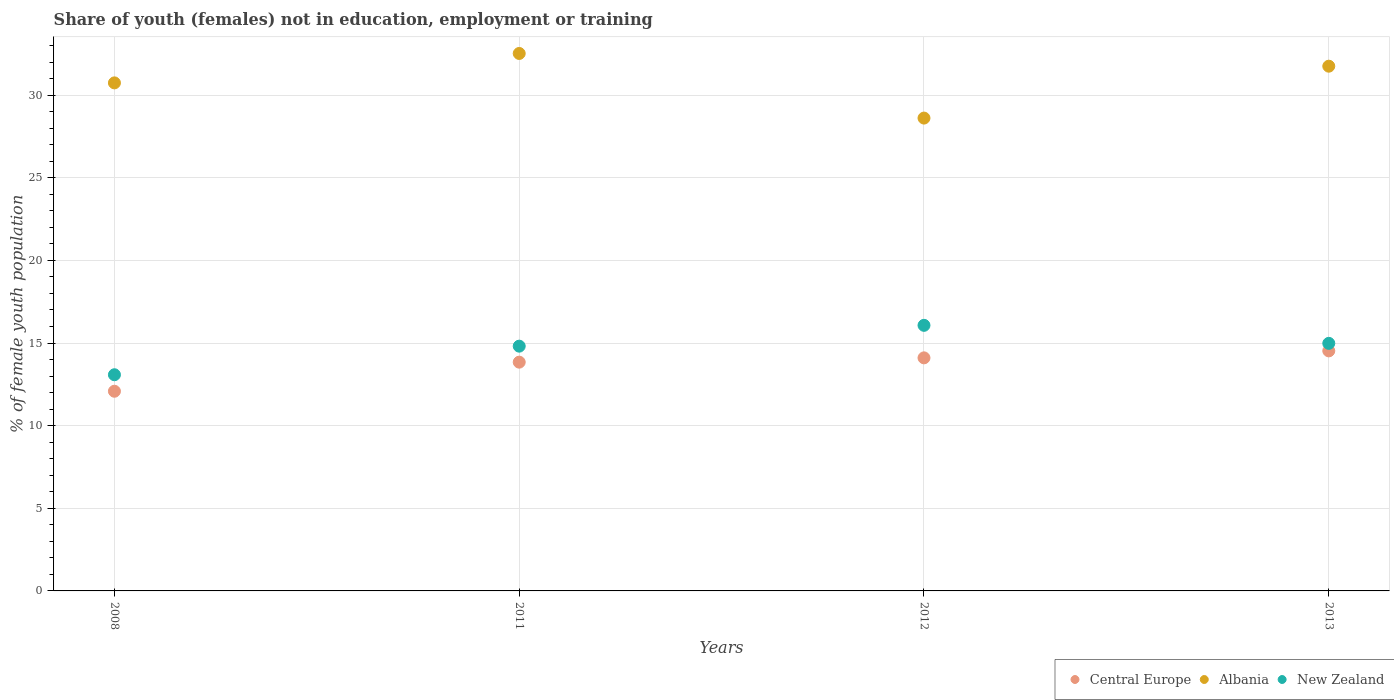How many different coloured dotlines are there?
Offer a very short reply. 3. Is the number of dotlines equal to the number of legend labels?
Offer a very short reply. Yes. What is the percentage of unemployed female population in in Albania in 2011?
Ensure brevity in your answer.  32.52. Across all years, what is the maximum percentage of unemployed female population in in Central Europe?
Offer a terse response. 14.52. Across all years, what is the minimum percentage of unemployed female population in in New Zealand?
Make the answer very short. 13.08. In which year was the percentage of unemployed female population in in New Zealand maximum?
Provide a succinct answer. 2012. In which year was the percentage of unemployed female population in in Central Europe minimum?
Provide a succinct answer. 2008. What is the total percentage of unemployed female population in in Albania in the graph?
Offer a terse response. 123.62. What is the difference between the percentage of unemployed female population in in Central Europe in 2012 and that in 2013?
Your response must be concise. -0.42. What is the difference between the percentage of unemployed female population in in New Zealand in 2008 and the percentage of unemployed female population in in Albania in 2012?
Offer a terse response. -15.53. What is the average percentage of unemployed female population in in Albania per year?
Your answer should be compact. 30.91. In the year 2012, what is the difference between the percentage of unemployed female population in in New Zealand and percentage of unemployed female population in in Central Europe?
Your response must be concise. 1.97. In how many years, is the percentage of unemployed female population in in New Zealand greater than 18 %?
Provide a succinct answer. 0. What is the ratio of the percentage of unemployed female population in in Albania in 2008 to that in 2011?
Offer a terse response. 0.95. What is the difference between the highest and the second highest percentage of unemployed female population in in Central Europe?
Ensure brevity in your answer.  0.42. What is the difference between the highest and the lowest percentage of unemployed female population in in Central Europe?
Offer a terse response. 2.44. In how many years, is the percentage of unemployed female population in in New Zealand greater than the average percentage of unemployed female population in in New Zealand taken over all years?
Keep it short and to the point. 3. Does the percentage of unemployed female population in in Albania monotonically increase over the years?
Ensure brevity in your answer.  No. Is the percentage of unemployed female population in in Central Europe strictly less than the percentage of unemployed female population in in Albania over the years?
Your response must be concise. Yes. How many years are there in the graph?
Provide a succinct answer. 4. Does the graph contain any zero values?
Your answer should be very brief. No. Does the graph contain grids?
Your answer should be very brief. Yes. Where does the legend appear in the graph?
Ensure brevity in your answer.  Bottom right. What is the title of the graph?
Your response must be concise. Share of youth (females) not in education, employment or training. Does "Euro area" appear as one of the legend labels in the graph?
Give a very brief answer. No. What is the label or title of the Y-axis?
Your response must be concise. % of female youth population. What is the % of female youth population of Central Europe in 2008?
Make the answer very short. 12.08. What is the % of female youth population in Albania in 2008?
Your response must be concise. 30.74. What is the % of female youth population of New Zealand in 2008?
Your response must be concise. 13.08. What is the % of female youth population of Central Europe in 2011?
Provide a succinct answer. 13.84. What is the % of female youth population of Albania in 2011?
Ensure brevity in your answer.  32.52. What is the % of female youth population in New Zealand in 2011?
Your response must be concise. 14.81. What is the % of female youth population of Central Europe in 2012?
Offer a very short reply. 14.1. What is the % of female youth population of Albania in 2012?
Provide a succinct answer. 28.61. What is the % of female youth population of New Zealand in 2012?
Offer a very short reply. 16.07. What is the % of female youth population of Central Europe in 2013?
Ensure brevity in your answer.  14.52. What is the % of female youth population of Albania in 2013?
Keep it short and to the point. 31.75. What is the % of female youth population in New Zealand in 2013?
Offer a very short reply. 14.98. Across all years, what is the maximum % of female youth population of Central Europe?
Your answer should be compact. 14.52. Across all years, what is the maximum % of female youth population of Albania?
Offer a very short reply. 32.52. Across all years, what is the maximum % of female youth population in New Zealand?
Offer a terse response. 16.07. Across all years, what is the minimum % of female youth population in Central Europe?
Make the answer very short. 12.08. Across all years, what is the minimum % of female youth population of Albania?
Offer a very short reply. 28.61. Across all years, what is the minimum % of female youth population of New Zealand?
Ensure brevity in your answer.  13.08. What is the total % of female youth population in Central Europe in the graph?
Your answer should be very brief. 54.55. What is the total % of female youth population in Albania in the graph?
Give a very brief answer. 123.62. What is the total % of female youth population of New Zealand in the graph?
Offer a very short reply. 58.94. What is the difference between the % of female youth population in Central Europe in 2008 and that in 2011?
Your answer should be very brief. -1.76. What is the difference between the % of female youth population in Albania in 2008 and that in 2011?
Keep it short and to the point. -1.78. What is the difference between the % of female youth population of New Zealand in 2008 and that in 2011?
Provide a succinct answer. -1.73. What is the difference between the % of female youth population of Central Europe in 2008 and that in 2012?
Provide a short and direct response. -2.02. What is the difference between the % of female youth population of Albania in 2008 and that in 2012?
Your answer should be compact. 2.13. What is the difference between the % of female youth population of New Zealand in 2008 and that in 2012?
Make the answer very short. -2.99. What is the difference between the % of female youth population in Central Europe in 2008 and that in 2013?
Keep it short and to the point. -2.44. What is the difference between the % of female youth population in Albania in 2008 and that in 2013?
Your response must be concise. -1.01. What is the difference between the % of female youth population in Central Europe in 2011 and that in 2012?
Your answer should be very brief. -0.26. What is the difference between the % of female youth population of Albania in 2011 and that in 2012?
Offer a terse response. 3.91. What is the difference between the % of female youth population in New Zealand in 2011 and that in 2012?
Make the answer very short. -1.26. What is the difference between the % of female youth population of Central Europe in 2011 and that in 2013?
Your answer should be very brief. -0.68. What is the difference between the % of female youth population of Albania in 2011 and that in 2013?
Your response must be concise. 0.77. What is the difference between the % of female youth population of New Zealand in 2011 and that in 2013?
Make the answer very short. -0.17. What is the difference between the % of female youth population of Central Europe in 2012 and that in 2013?
Give a very brief answer. -0.42. What is the difference between the % of female youth population of Albania in 2012 and that in 2013?
Ensure brevity in your answer.  -3.14. What is the difference between the % of female youth population of New Zealand in 2012 and that in 2013?
Ensure brevity in your answer.  1.09. What is the difference between the % of female youth population of Central Europe in 2008 and the % of female youth population of Albania in 2011?
Give a very brief answer. -20.44. What is the difference between the % of female youth population of Central Europe in 2008 and the % of female youth population of New Zealand in 2011?
Make the answer very short. -2.73. What is the difference between the % of female youth population in Albania in 2008 and the % of female youth population in New Zealand in 2011?
Give a very brief answer. 15.93. What is the difference between the % of female youth population in Central Europe in 2008 and the % of female youth population in Albania in 2012?
Give a very brief answer. -16.53. What is the difference between the % of female youth population of Central Europe in 2008 and the % of female youth population of New Zealand in 2012?
Offer a very short reply. -3.99. What is the difference between the % of female youth population in Albania in 2008 and the % of female youth population in New Zealand in 2012?
Ensure brevity in your answer.  14.67. What is the difference between the % of female youth population in Central Europe in 2008 and the % of female youth population in Albania in 2013?
Give a very brief answer. -19.67. What is the difference between the % of female youth population of Central Europe in 2008 and the % of female youth population of New Zealand in 2013?
Provide a short and direct response. -2.9. What is the difference between the % of female youth population of Albania in 2008 and the % of female youth population of New Zealand in 2013?
Your response must be concise. 15.76. What is the difference between the % of female youth population in Central Europe in 2011 and the % of female youth population in Albania in 2012?
Your answer should be very brief. -14.77. What is the difference between the % of female youth population of Central Europe in 2011 and the % of female youth population of New Zealand in 2012?
Your response must be concise. -2.23. What is the difference between the % of female youth population of Albania in 2011 and the % of female youth population of New Zealand in 2012?
Your response must be concise. 16.45. What is the difference between the % of female youth population in Central Europe in 2011 and the % of female youth population in Albania in 2013?
Offer a very short reply. -17.91. What is the difference between the % of female youth population in Central Europe in 2011 and the % of female youth population in New Zealand in 2013?
Keep it short and to the point. -1.14. What is the difference between the % of female youth population of Albania in 2011 and the % of female youth population of New Zealand in 2013?
Ensure brevity in your answer.  17.54. What is the difference between the % of female youth population in Central Europe in 2012 and the % of female youth population in Albania in 2013?
Give a very brief answer. -17.65. What is the difference between the % of female youth population in Central Europe in 2012 and the % of female youth population in New Zealand in 2013?
Give a very brief answer. -0.88. What is the difference between the % of female youth population in Albania in 2012 and the % of female youth population in New Zealand in 2013?
Your answer should be very brief. 13.63. What is the average % of female youth population in Central Europe per year?
Give a very brief answer. 13.64. What is the average % of female youth population in Albania per year?
Offer a terse response. 30.91. What is the average % of female youth population in New Zealand per year?
Your answer should be compact. 14.73. In the year 2008, what is the difference between the % of female youth population of Central Europe and % of female youth population of Albania?
Make the answer very short. -18.66. In the year 2008, what is the difference between the % of female youth population in Central Europe and % of female youth population in New Zealand?
Your answer should be very brief. -1. In the year 2008, what is the difference between the % of female youth population in Albania and % of female youth population in New Zealand?
Keep it short and to the point. 17.66. In the year 2011, what is the difference between the % of female youth population in Central Europe and % of female youth population in Albania?
Offer a terse response. -18.68. In the year 2011, what is the difference between the % of female youth population of Central Europe and % of female youth population of New Zealand?
Offer a terse response. -0.97. In the year 2011, what is the difference between the % of female youth population of Albania and % of female youth population of New Zealand?
Provide a short and direct response. 17.71. In the year 2012, what is the difference between the % of female youth population in Central Europe and % of female youth population in Albania?
Keep it short and to the point. -14.51. In the year 2012, what is the difference between the % of female youth population of Central Europe and % of female youth population of New Zealand?
Keep it short and to the point. -1.97. In the year 2012, what is the difference between the % of female youth population of Albania and % of female youth population of New Zealand?
Your answer should be compact. 12.54. In the year 2013, what is the difference between the % of female youth population of Central Europe and % of female youth population of Albania?
Make the answer very short. -17.23. In the year 2013, what is the difference between the % of female youth population in Central Europe and % of female youth population in New Zealand?
Keep it short and to the point. -0.46. In the year 2013, what is the difference between the % of female youth population in Albania and % of female youth population in New Zealand?
Ensure brevity in your answer.  16.77. What is the ratio of the % of female youth population of Central Europe in 2008 to that in 2011?
Your response must be concise. 0.87. What is the ratio of the % of female youth population in Albania in 2008 to that in 2011?
Keep it short and to the point. 0.95. What is the ratio of the % of female youth population in New Zealand in 2008 to that in 2011?
Your response must be concise. 0.88. What is the ratio of the % of female youth population in Central Europe in 2008 to that in 2012?
Provide a succinct answer. 0.86. What is the ratio of the % of female youth population in Albania in 2008 to that in 2012?
Provide a short and direct response. 1.07. What is the ratio of the % of female youth population in New Zealand in 2008 to that in 2012?
Offer a terse response. 0.81. What is the ratio of the % of female youth population of Central Europe in 2008 to that in 2013?
Keep it short and to the point. 0.83. What is the ratio of the % of female youth population in Albania in 2008 to that in 2013?
Your answer should be compact. 0.97. What is the ratio of the % of female youth population of New Zealand in 2008 to that in 2013?
Provide a succinct answer. 0.87. What is the ratio of the % of female youth population of Central Europe in 2011 to that in 2012?
Offer a terse response. 0.98. What is the ratio of the % of female youth population in Albania in 2011 to that in 2012?
Your response must be concise. 1.14. What is the ratio of the % of female youth population of New Zealand in 2011 to that in 2012?
Provide a short and direct response. 0.92. What is the ratio of the % of female youth population of Central Europe in 2011 to that in 2013?
Keep it short and to the point. 0.95. What is the ratio of the % of female youth population of Albania in 2011 to that in 2013?
Your response must be concise. 1.02. What is the ratio of the % of female youth population of New Zealand in 2011 to that in 2013?
Offer a terse response. 0.99. What is the ratio of the % of female youth population of Central Europe in 2012 to that in 2013?
Your answer should be compact. 0.97. What is the ratio of the % of female youth population of Albania in 2012 to that in 2013?
Your response must be concise. 0.9. What is the ratio of the % of female youth population in New Zealand in 2012 to that in 2013?
Offer a terse response. 1.07. What is the difference between the highest and the second highest % of female youth population in Central Europe?
Keep it short and to the point. 0.42. What is the difference between the highest and the second highest % of female youth population of Albania?
Ensure brevity in your answer.  0.77. What is the difference between the highest and the second highest % of female youth population of New Zealand?
Your answer should be very brief. 1.09. What is the difference between the highest and the lowest % of female youth population in Central Europe?
Make the answer very short. 2.44. What is the difference between the highest and the lowest % of female youth population in Albania?
Your answer should be very brief. 3.91. What is the difference between the highest and the lowest % of female youth population in New Zealand?
Keep it short and to the point. 2.99. 